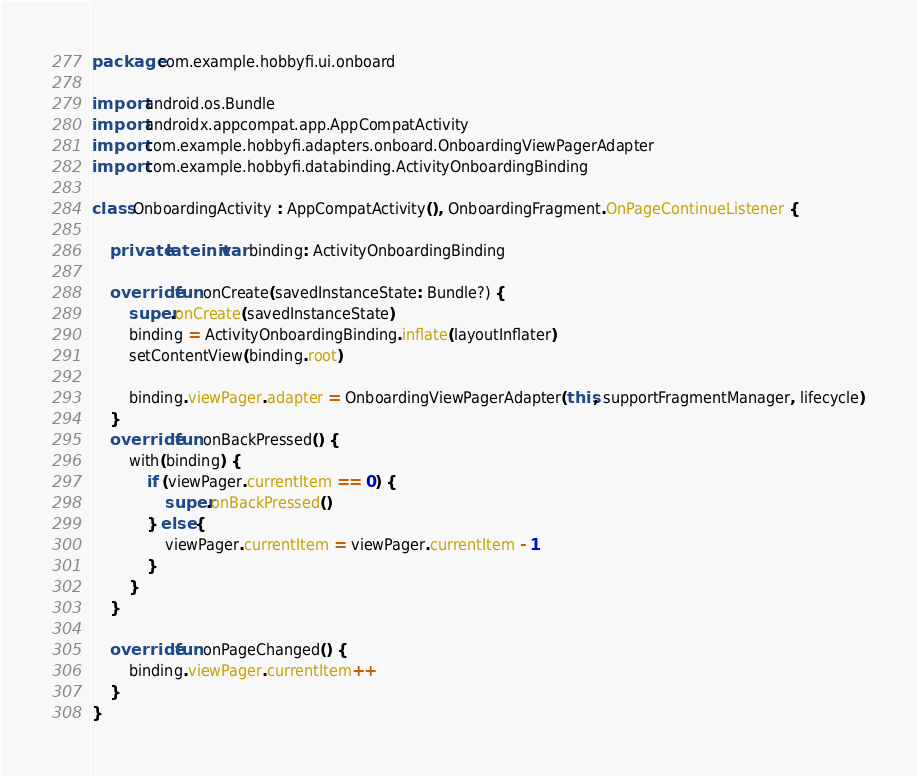<code> <loc_0><loc_0><loc_500><loc_500><_Kotlin_>package com.example.hobbyfi.ui.onboard

import android.os.Bundle
import androidx.appcompat.app.AppCompatActivity
import com.example.hobbyfi.adapters.onboard.OnboardingViewPagerAdapter
import com.example.hobbyfi.databinding.ActivityOnboardingBinding

class OnboardingActivity : AppCompatActivity(), OnboardingFragment.OnPageContinueListener {

    private lateinit var binding: ActivityOnboardingBinding

    override fun onCreate(savedInstanceState: Bundle?) {
        super.onCreate(savedInstanceState)
        binding = ActivityOnboardingBinding.inflate(layoutInflater)
        setContentView(binding.root)

        binding.viewPager.adapter = OnboardingViewPagerAdapter(this, supportFragmentManager, lifecycle)
    }
    override fun onBackPressed() {
        with(binding) {
            if (viewPager.currentItem == 0) {
                super.onBackPressed()
            } else {
                viewPager.currentItem = viewPager.currentItem - 1
            }
        }
    }

    override fun onPageChanged() {
        binding.viewPager.currentItem++
    }
}</code> 